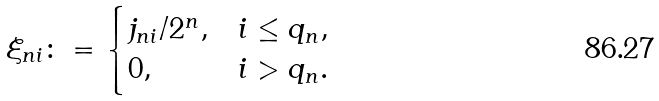<formula> <loc_0><loc_0><loc_500><loc_500>\xi _ { n i } \colon = \begin{cases} j _ { n i } / 2 ^ { n } , & i \leq q _ { n } , \\ 0 , & i > q _ { n } . \end{cases}</formula> 